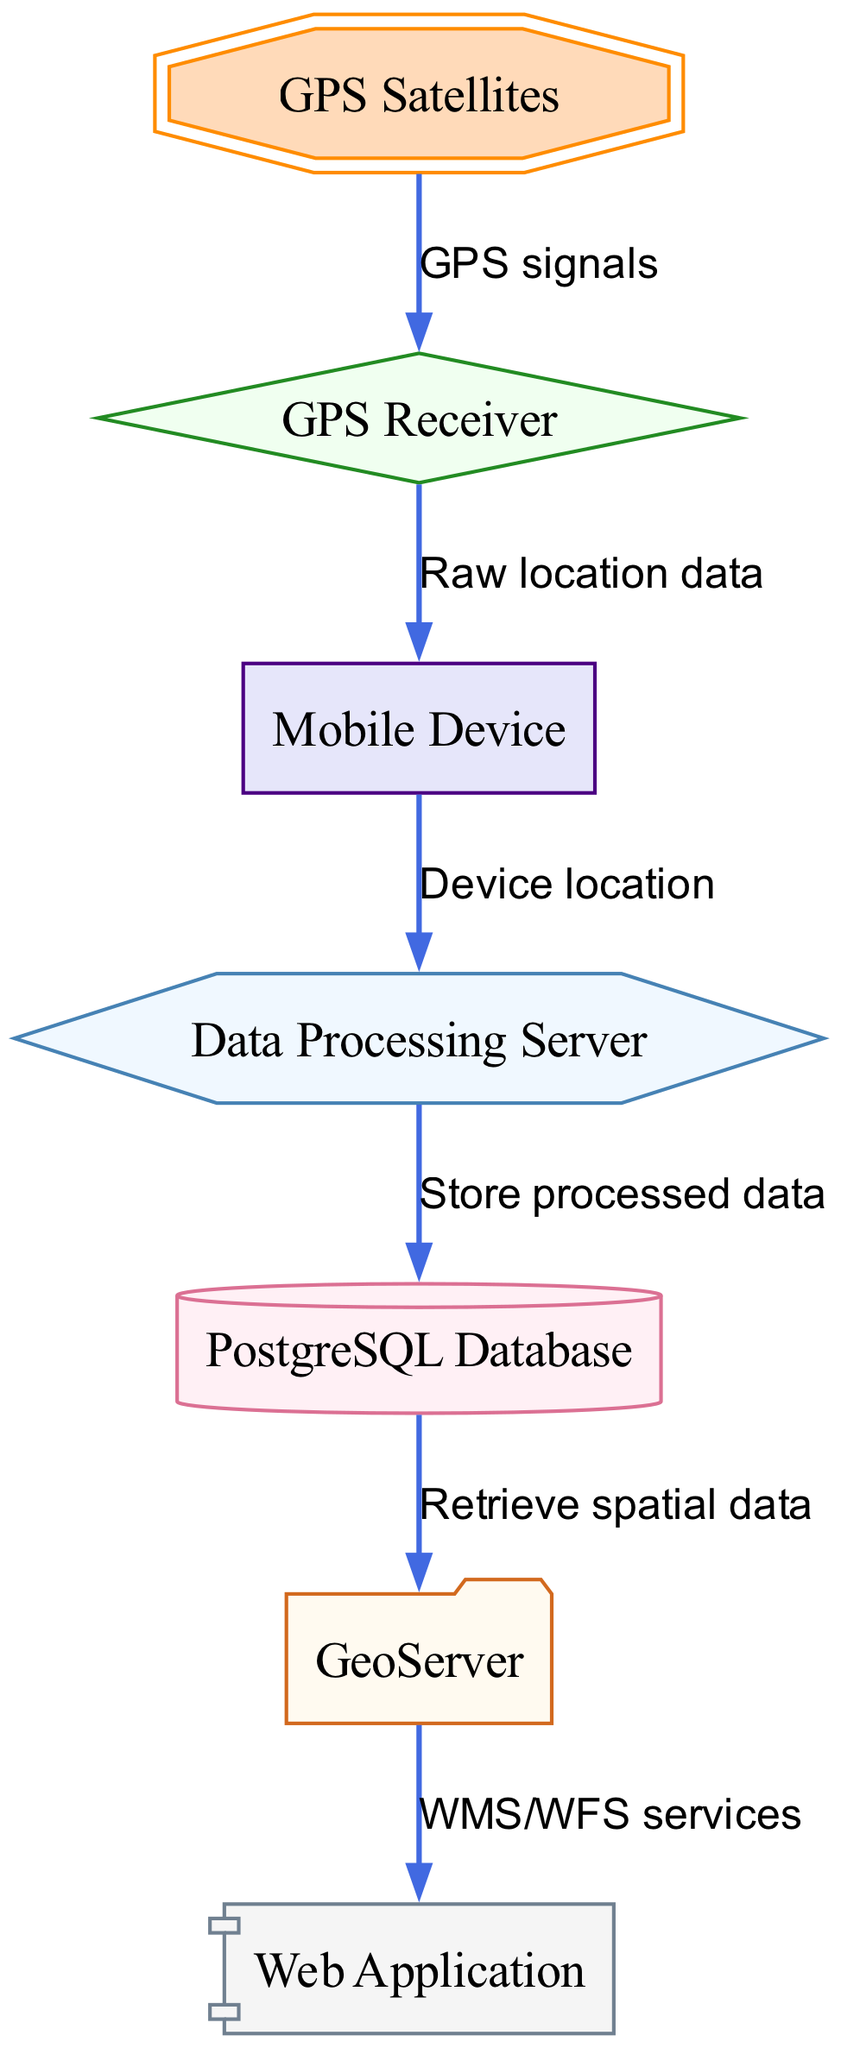What is the total number of nodes in the diagram? The diagram contains a list of nodes, which can be counted. There are seven nodes: GPS Satellites, Mobile Device, GPS Receiver, Data Processing Server, PostgreSQL Database, GeoServer, and Web Application.
Answer: 7 What kind of signals are sent from GPS Satellites to the GPS Receiver? The diagram specifies the edge from GPS Satellites to GPS Receiver, which is labeled as "GPS signals." This label indicates the type of data being transmitted.
Answer: GPS signals Which component retrieves spatial data from the PostgreSQL Database? According to the diagram, there is a connection from the PostgreSQL Database to the GeoServer labeled "Retrieve spatial data," indicating that the GeoServer is responsible for this action.
Answer: GeoServer How many edges connect Mobile Device to other components in the diagram? By examining the edges connected from the Mobile Device (Node 2), there are two outgoing edges: one to the GPS Receiver and one to the Data Processing Server. Therefore, the count of edges is two.
Answer: 2 What is the relationship between the Data Processing Server and the PostgreSQL Database? The edge from the Data Processing Server to the PostgreSQL Database is labeled "Store processed data." This indicates that the Data Processing Server stores data in the PostgreSQL Database.
Answer: Store processed data Which node outputs WMS/WFS services? The edge directed from GeoServer to the Web Application is labeled "WMS/WFS services." This indicates that the GeoServer is the source of these services, which are sent to the Web Application.
Answer: GeoServer If the Mobile Device sends its location to the Data Processing Server, what is this data referred to as? The edge from Mobile Device to Data Processing Server is labeled "Device location." Therefore, the data type that the Mobile Device sends is referred to as Device location.
Answer: Device location What shape is used to represent the GPS Receiver in the diagram? The diagram specifies the GPS Receiver as a diamond shape. Looking at the node styles provided, the GPS Receiver is described as having a shape of "diamond."
Answer: diamond 